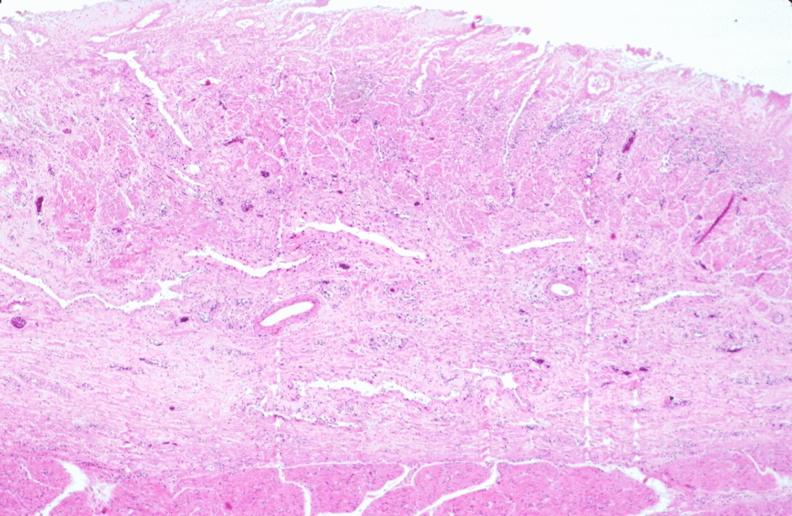what does this image show?
Answer the question using a single word or phrase. Stomach 